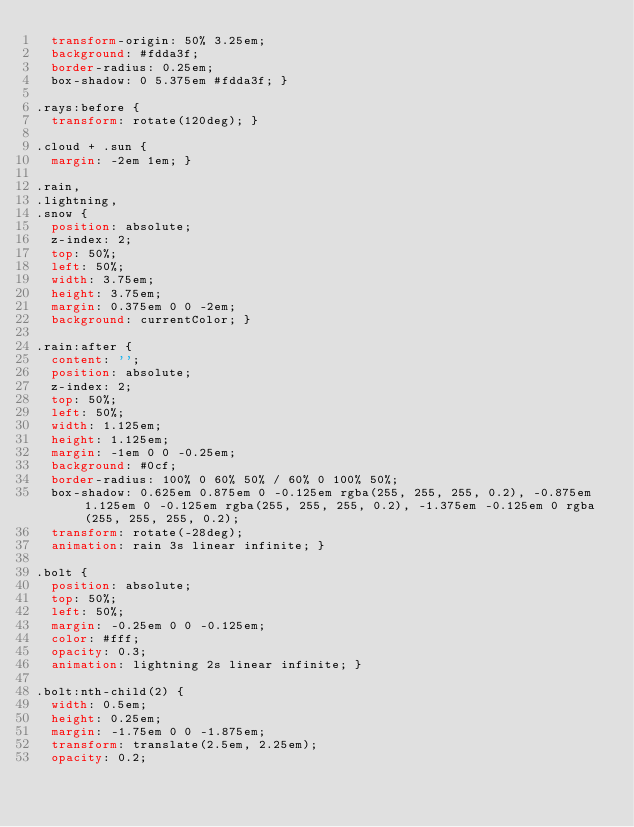Convert code to text. <code><loc_0><loc_0><loc_500><loc_500><_CSS_>  transform-origin: 50% 3.25em;
  background: #fdda3f;
  border-radius: 0.25em;
  box-shadow: 0 5.375em #fdda3f; }

.rays:before {
  transform: rotate(120deg); }

.cloud + .sun {
  margin: -2em 1em; }

.rain,
.lightning,
.snow {
  position: absolute;
  z-index: 2;
  top: 50%;
  left: 50%;
  width: 3.75em;
  height: 3.75em;
  margin: 0.375em 0 0 -2em;
  background: currentColor; }

.rain:after {
  content: '';
  position: absolute;
  z-index: 2;
  top: 50%;
  left: 50%;
  width: 1.125em;
  height: 1.125em;
  margin: -1em 0 0 -0.25em;
  background: #0cf;
  border-radius: 100% 0 60% 50% / 60% 0 100% 50%;
  box-shadow: 0.625em 0.875em 0 -0.125em rgba(255, 255, 255, 0.2), -0.875em 1.125em 0 -0.125em rgba(255, 255, 255, 0.2), -1.375em -0.125em 0 rgba(255, 255, 255, 0.2);
  transform: rotate(-28deg);
  animation: rain 3s linear infinite; }

.bolt {
  position: absolute;
  top: 50%;
  left: 50%;
  margin: -0.25em 0 0 -0.125em;
  color: #fff;
  opacity: 0.3;
  animation: lightning 2s linear infinite; }

.bolt:nth-child(2) {
  width: 0.5em;
  height: 0.25em;
  margin: -1.75em 0 0 -1.875em;
  transform: translate(2.5em, 2.25em);
  opacity: 0.2;</code> 